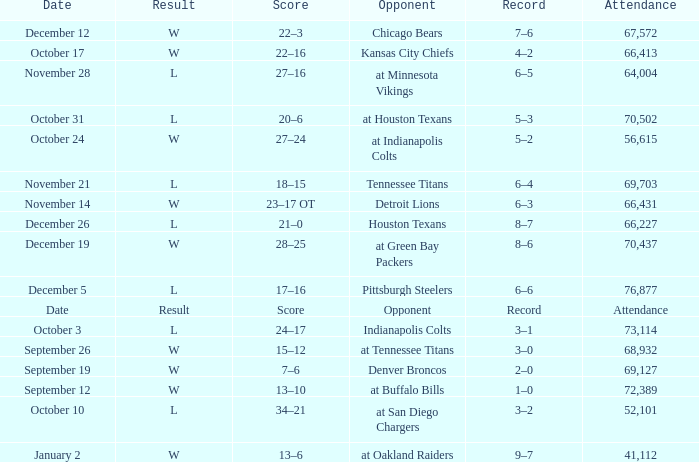What is the score with an october 31 date? 20–6. 